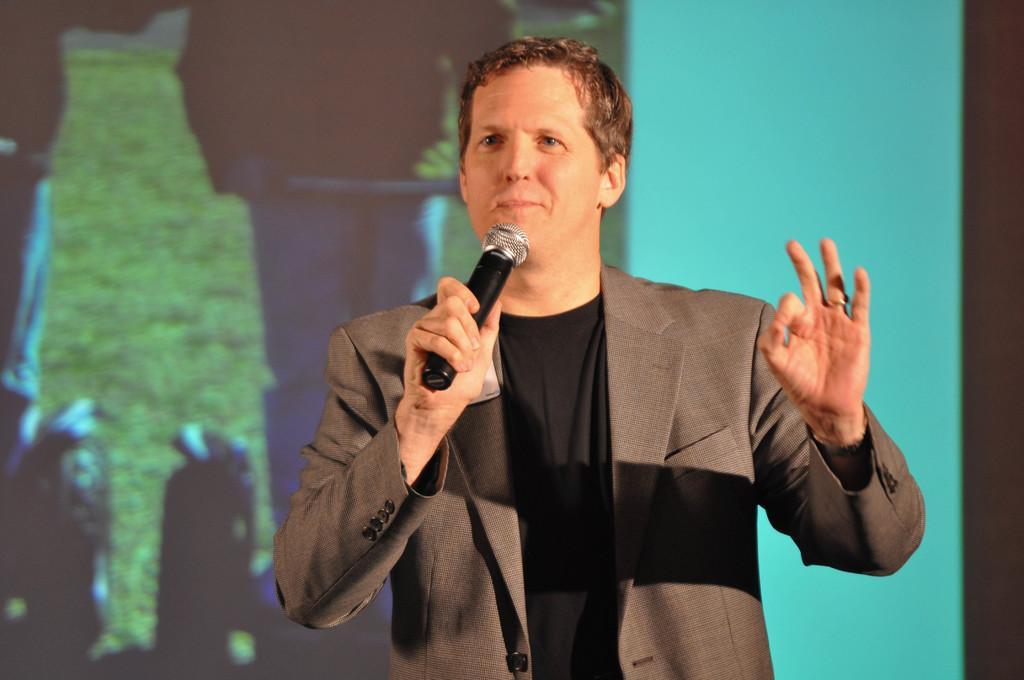Please provide a concise description of this image. A man is standing and holding a microphone. He wear a coat. 